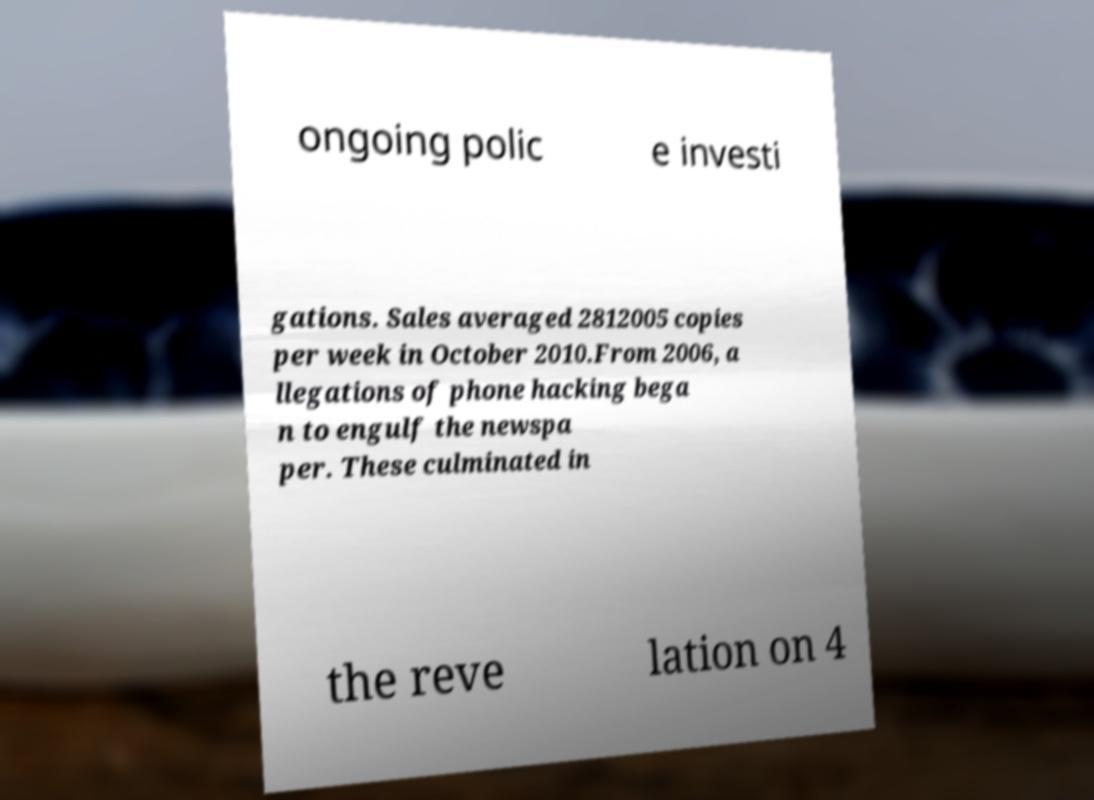There's text embedded in this image that I need extracted. Can you transcribe it verbatim? ongoing polic e investi gations. Sales averaged 2812005 copies per week in October 2010.From 2006, a llegations of phone hacking bega n to engulf the newspa per. These culminated in the reve lation on 4 